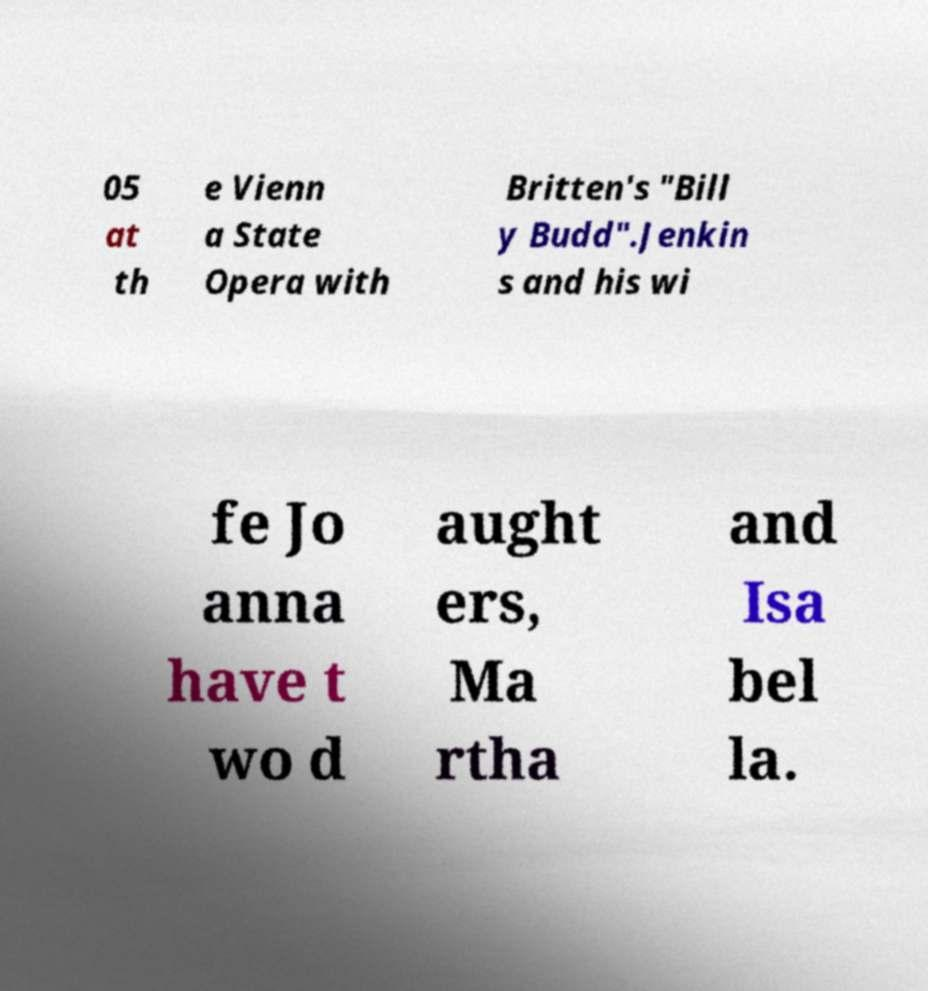For documentation purposes, I need the text within this image transcribed. Could you provide that? 05 at th e Vienn a State Opera with Britten's "Bill y Budd".Jenkin s and his wi fe Jo anna have t wo d aught ers, Ma rtha and Isa bel la. 